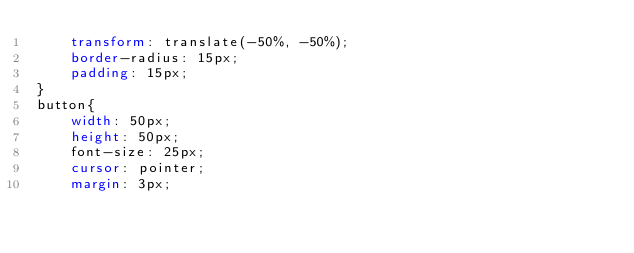Convert code to text. <code><loc_0><loc_0><loc_500><loc_500><_CSS_>    transform: translate(-50%, -50%);
    border-radius: 15px;
    padding: 15px;
}
button{
    width: 50px;
    height: 50px;
    font-size: 25px;
    cursor: pointer;
    margin: 3px;</code> 